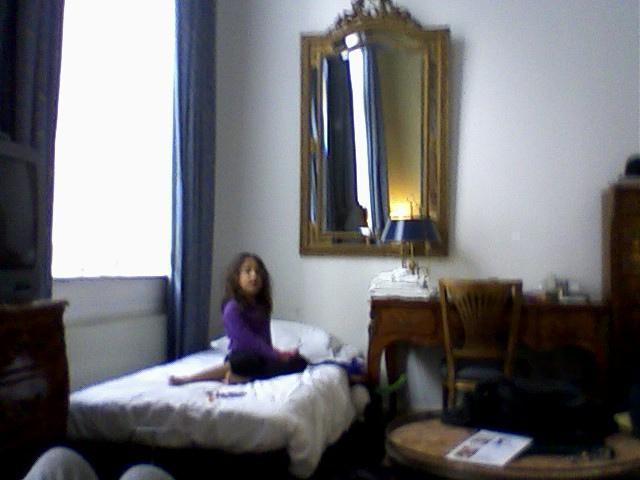Why is the image blurred?
Select the accurate response from the four choices given to answer the question.
Options: Shaky photographer, unfocussed, girl moving, broken camera. Unfocussed. 